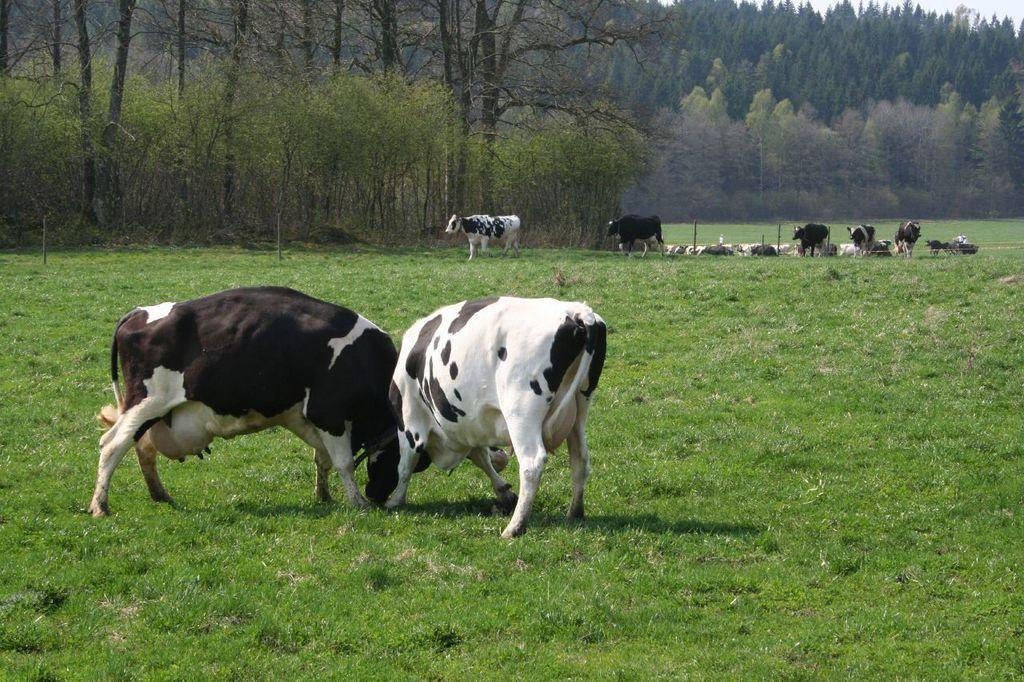What animals are in the center of the image? There are cows in the center of the image. What type of vegetation can be seen in the background of the image? There are trees in the background of the image. What type of ground is visible at the bottom of the image? There is grass at the bottom of the image. What type of tax is being discussed in the image? There is no discussion of tax in the image; it features cows, trees, and grass. What kind of mask is being worn by the cows in the image? There are no masks present in the image; the cows are not wearing any masks. 